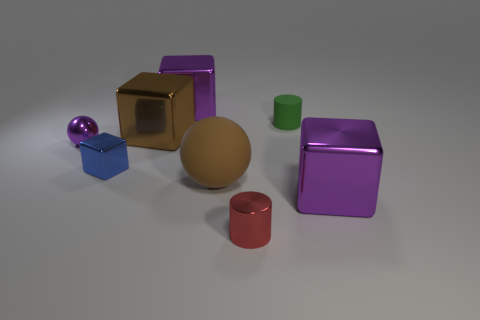Subtract all blue cubes. How many cubes are left? 3 Add 2 green objects. How many objects exist? 10 Subtract all blue cubes. How many cubes are left? 3 Subtract all cylinders. How many objects are left? 6 Subtract all gray spheres. How many yellow cylinders are left? 0 Add 3 small purple things. How many small purple things are left? 4 Add 1 purple metallic things. How many purple metallic things exist? 4 Subtract 0 blue cylinders. How many objects are left? 8 Subtract 1 blocks. How many blocks are left? 3 Subtract all brown cylinders. Subtract all yellow spheres. How many cylinders are left? 2 